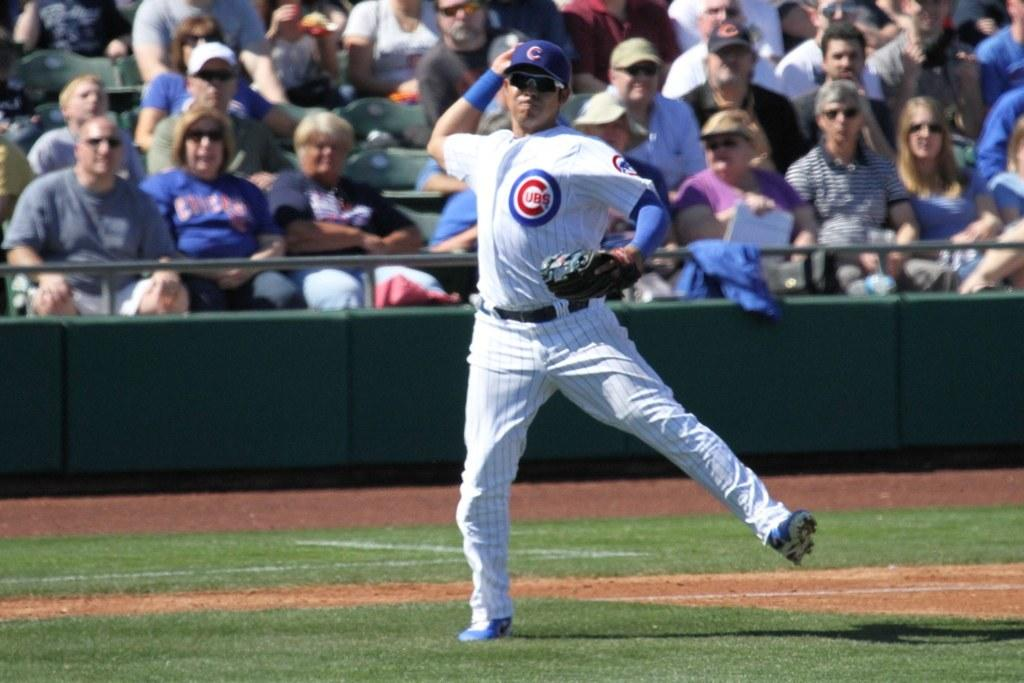<image>
Offer a succinct explanation of the picture presented. a man in a cubs uniform playing baseball 